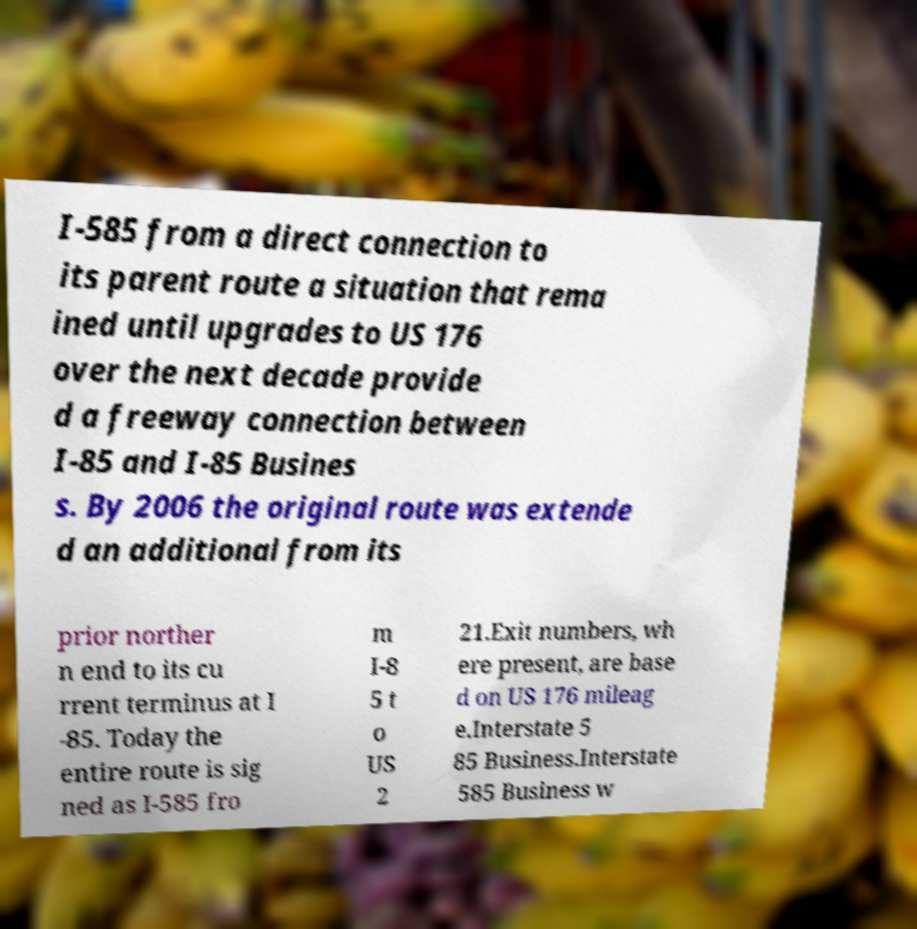I need the written content from this picture converted into text. Can you do that? I-585 from a direct connection to its parent route a situation that rema ined until upgrades to US 176 over the next decade provide d a freeway connection between I-85 and I-85 Busines s. By 2006 the original route was extende d an additional from its prior norther n end to its cu rrent terminus at I -85. Today the entire route is sig ned as I-585 fro m I-8 5 t o US 2 21.Exit numbers, wh ere present, are base d on US 176 mileag e.Interstate 5 85 Business.Interstate 585 Business w 